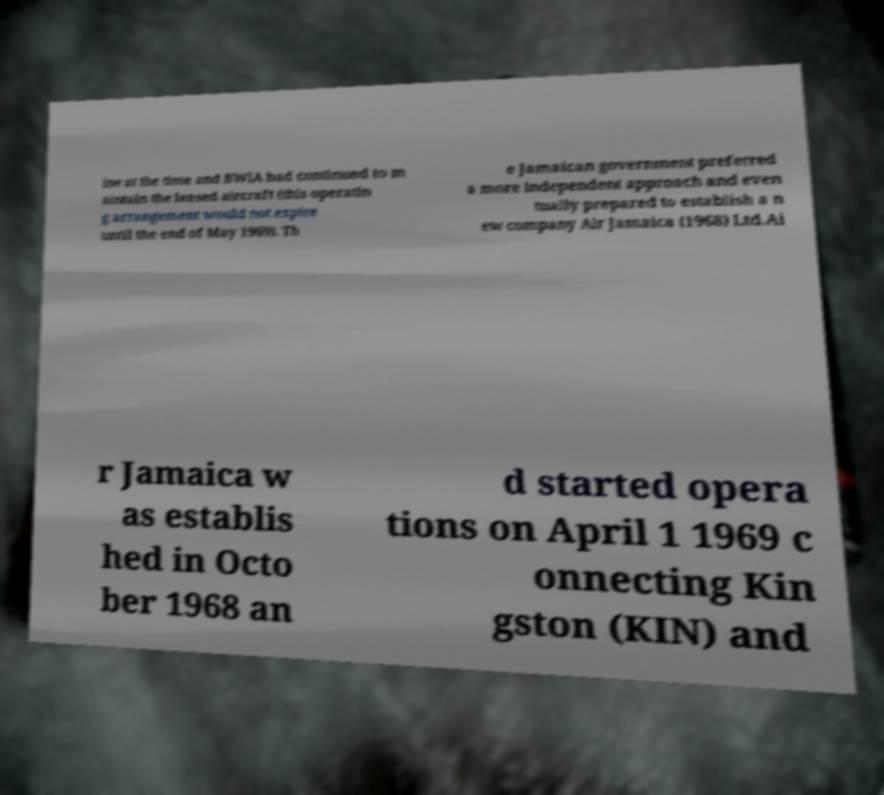Could you assist in decoding the text presented in this image and type it out clearly? ine at the time and BWIA had continued to m aintain the leased aircraft (this operatin g arrangement would not expire until the end of May 1969). Th e Jamaican government preferred a more independent approach and even tually prepared to establish a n ew company Air Jamaica (1968) Ltd.Ai r Jamaica w as establis hed in Octo ber 1968 an d started opera tions on April 1 1969 c onnecting Kin gston (KIN) and 